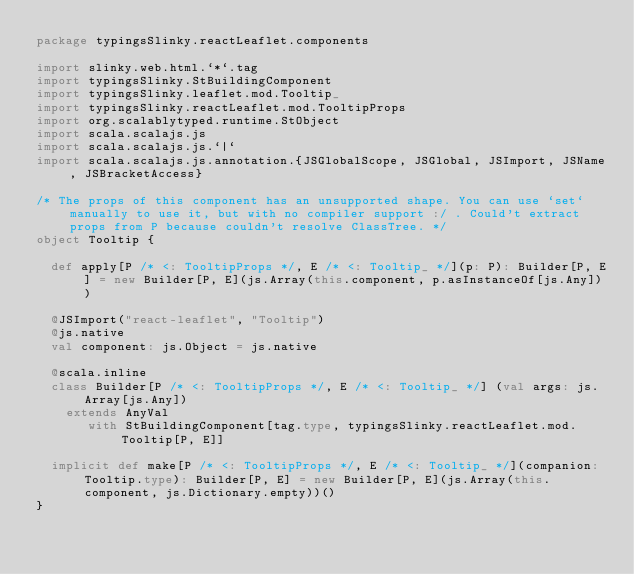Convert code to text. <code><loc_0><loc_0><loc_500><loc_500><_Scala_>package typingsSlinky.reactLeaflet.components

import slinky.web.html.`*`.tag
import typingsSlinky.StBuildingComponent
import typingsSlinky.leaflet.mod.Tooltip_
import typingsSlinky.reactLeaflet.mod.TooltipProps
import org.scalablytyped.runtime.StObject
import scala.scalajs.js
import scala.scalajs.js.`|`
import scala.scalajs.js.annotation.{JSGlobalScope, JSGlobal, JSImport, JSName, JSBracketAccess}

/* The props of this component has an unsupported shape. You can use `set` manually to use it, but with no compiler support :/ . Could't extract props from P because couldn't resolve ClassTree. */
object Tooltip {
  
  def apply[P /* <: TooltipProps */, E /* <: Tooltip_ */](p: P): Builder[P, E] = new Builder[P, E](js.Array(this.component, p.asInstanceOf[js.Any]))
  
  @JSImport("react-leaflet", "Tooltip")
  @js.native
  val component: js.Object = js.native
  
  @scala.inline
  class Builder[P /* <: TooltipProps */, E /* <: Tooltip_ */] (val args: js.Array[js.Any])
    extends AnyVal
       with StBuildingComponent[tag.type, typingsSlinky.reactLeaflet.mod.Tooltip[P, E]]
  
  implicit def make[P /* <: TooltipProps */, E /* <: Tooltip_ */](companion: Tooltip.type): Builder[P, E] = new Builder[P, E](js.Array(this.component, js.Dictionary.empty))()
}
</code> 